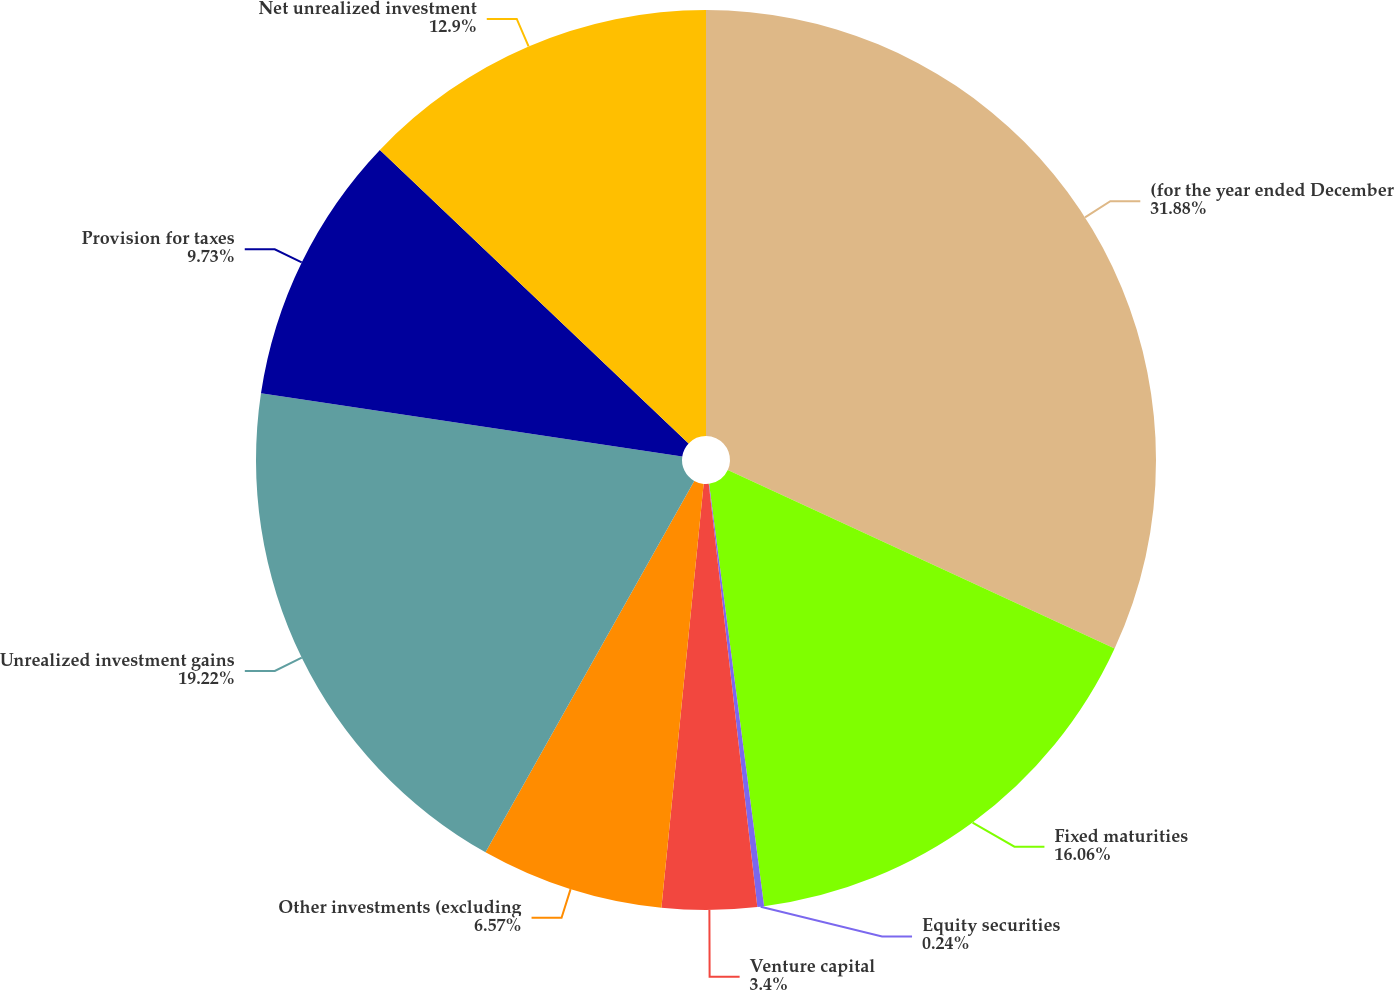Convert chart to OTSL. <chart><loc_0><loc_0><loc_500><loc_500><pie_chart><fcel>(for the year ended December<fcel>Fixed maturities<fcel>Equity securities<fcel>Venture capital<fcel>Other investments (excluding<fcel>Unrealized investment gains<fcel>Provision for taxes<fcel>Net unrealized investment<nl><fcel>31.88%<fcel>16.06%<fcel>0.24%<fcel>3.4%<fcel>6.57%<fcel>19.22%<fcel>9.73%<fcel>12.9%<nl></chart> 